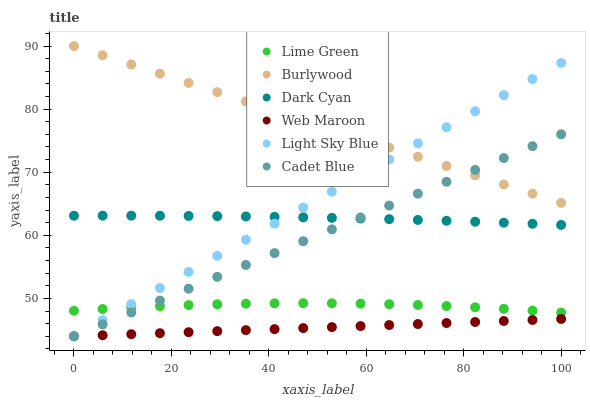Does Web Maroon have the minimum area under the curve?
Answer yes or no. Yes. Does Burlywood have the maximum area under the curve?
Answer yes or no. Yes. Does Burlywood have the minimum area under the curve?
Answer yes or no. No. Does Web Maroon have the maximum area under the curve?
Answer yes or no. No. Is Web Maroon the smoothest?
Answer yes or no. Yes. Is Lime Green the roughest?
Answer yes or no. Yes. Is Burlywood the smoothest?
Answer yes or no. No. Is Burlywood the roughest?
Answer yes or no. No. Does Cadet Blue have the lowest value?
Answer yes or no. Yes. Does Burlywood have the lowest value?
Answer yes or no. No. Does Burlywood have the highest value?
Answer yes or no. Yes. Does Web Maroon have the highest value?
Answer yes or no. No. Is Lime Green less than Burlywood?
Answer yes or no. Yes. Is Burlywood greater than Web Maroon?
Answer yes or no. Yes. Does Light Sky Blue intersect Burlywood?
Answer yes or no. Yes. Is Light Sky Blue less than Burlywood?
Answer yes or no. No. Is Light Sky Blue greater than Burlywood?
Answer yes or no. No. Does Lime Green intersect Burlywood?
Answer yes or no. No. 